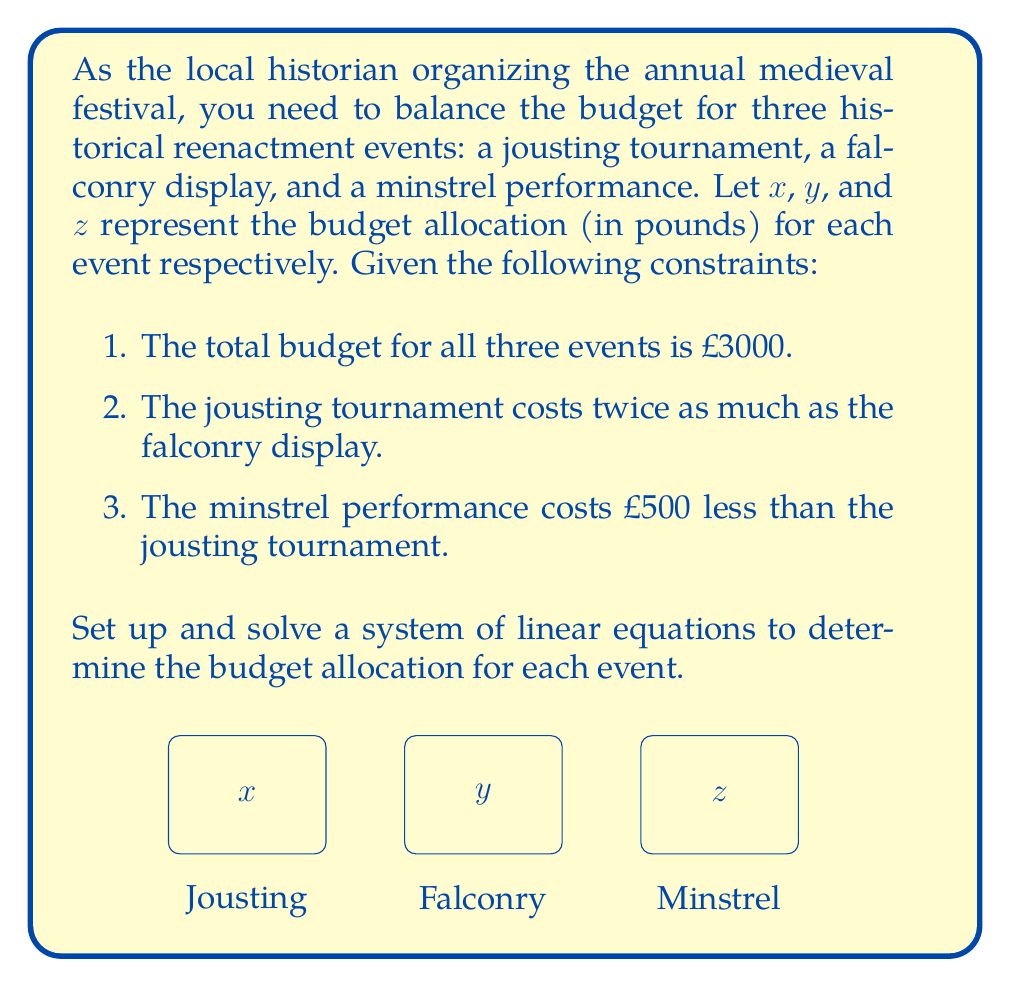Could you help me with this problem? Let's approach this step-by-step:

1) First, let's define our variables:
   $x$ = budget for jousting tournament
   $y$ = budget for falconry display
   $z$ = budget for minstrel performance

2) Now, let's translate the given constraints into equations:

   a) Total budget: $x + y + z = 3000$
   b) Jousting costs twice as much as falconry: $x = 2y$
   c) Minstrel costs £500 less than jousting: $z = x - 500$

3) We now have a system of three equations with three unknowns:

   $$\begin{cases}
   x + y + z = 3000 \\
   x = 2y \\
   z = x - 500
   \end{cases}$$

4) Let's substitute the second and third equations into the first:

   $2y + y + (2y - 500) = 3000$

5) Simplify:

   $5y - 500 = 3000$

6) Solve for $y$:

   $5y = 3500$
   $y = 700$

7) Now we can find $x$ and $z$:

   $x = 2y = 2(700) = 1400$
   $z = x - 500 = 1400 - 500 = 900$

8) Let's verify that these values satisfy all conditions:
   - Total budget: $1400 + 700 + 900 = 3000$ ✓
   - Jousting (1400) is twice falconry (700) ✓
   - Minstrel (900) is 500 less than jousting (1400) ✓

Therefore, the budget allocations are:
Jousting tournament: £1400
Falconry display: £700
Minstrel performance: £900
Answer: $x = 1400, y = 700, z = 900$ 